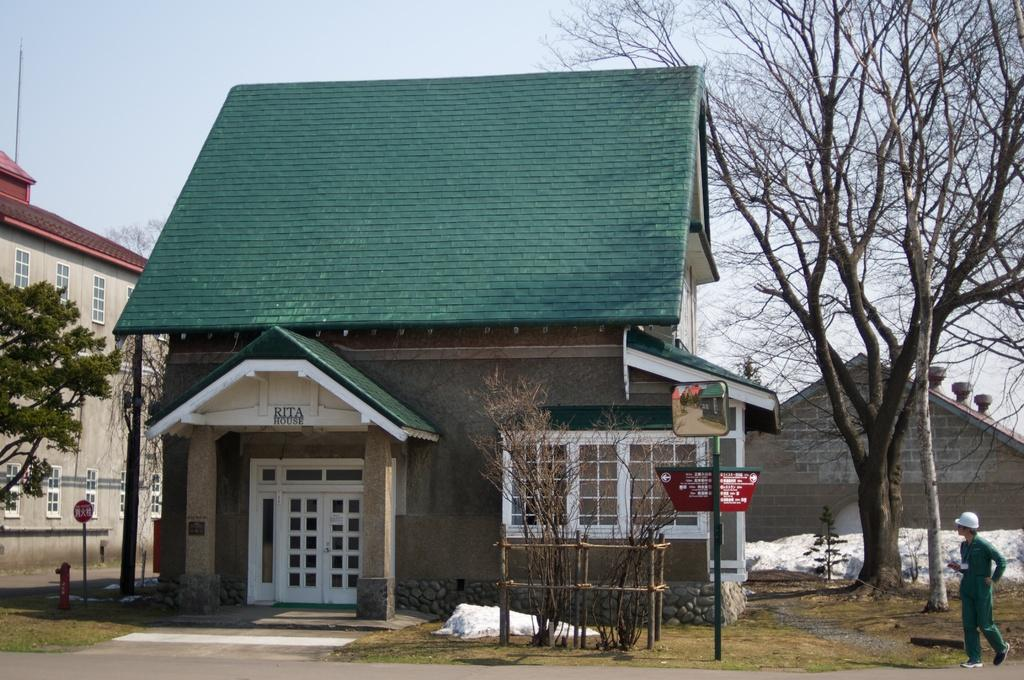What type of structures can be seen in the image? There are buildings in the image. Can you describe a specific feature of one of the buildings? There is a white door on one of the buildings. What other elements are present in the image besides the buildings? There are windows, trees, a pole, sign boards, a fire-hydrant, and snow in the image. What is the color of the sky in the image? The sky is in white and blue color. Is there any human presence in the image? Yes, there is a person standing in the image. What type of wound can be seen on the person's arm in the image? There is no wound visible on the person's arm in the image. What type of lace is used to decorate the buildings in the image? There is no lace used to decorate the buildings in the image. 